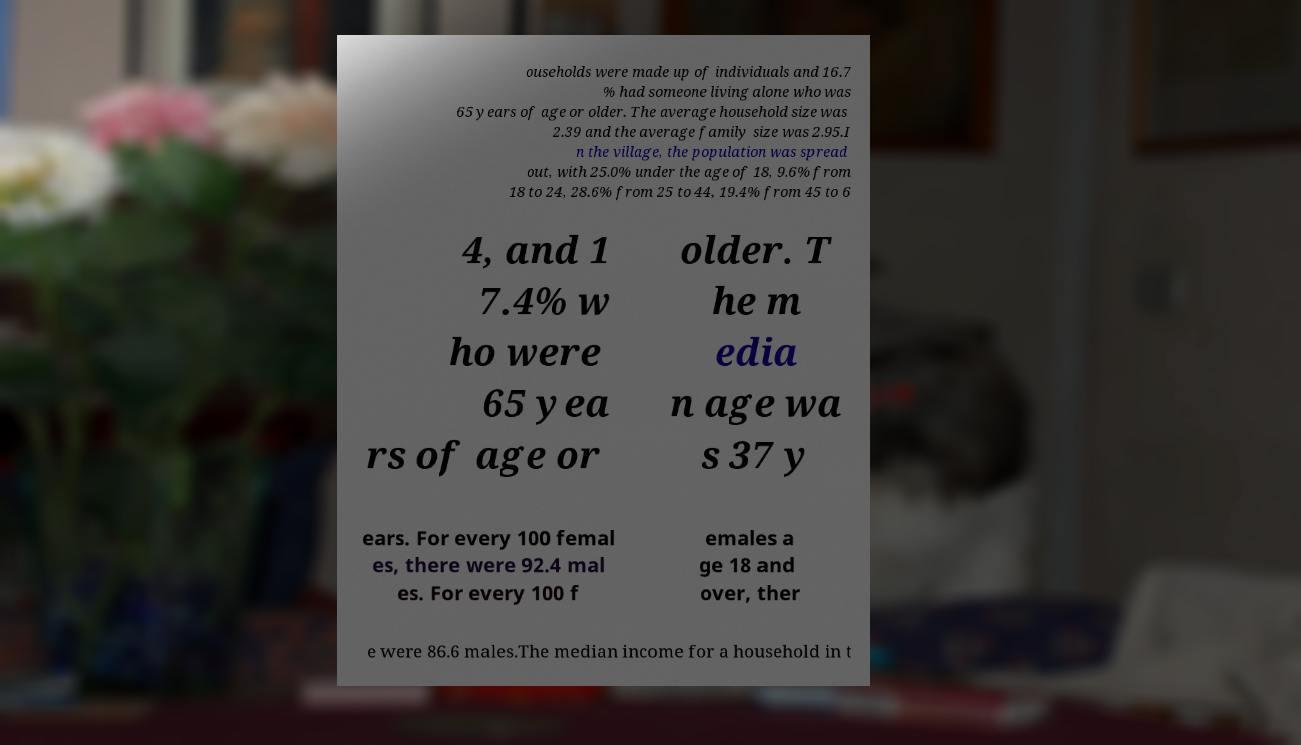Can you read and provide the text displayed in the image?This photo seems to have some interesting text. Can you extract and type it out for me? ouseholds were made up of individuals and 16.7 % had someone living alone who was 65 years of age or older. The average household size was 2.39 and the average family size was 2.95.I n the village, the population was spread out, with 25.0% under the age of 18, 9.6% from 18 to 24, 28.6% from 25 to 44, 19.4% from 45 to 6 4, and 1 7.4% w ho were 65 yea rs of age or older. T he m edia n age wa s 37 y ears. For every 100 femal es, there were 92.4 mal es. For every 100 f emales a ge 18 and over, ther e were 86.6 males.The median income for a household in t 